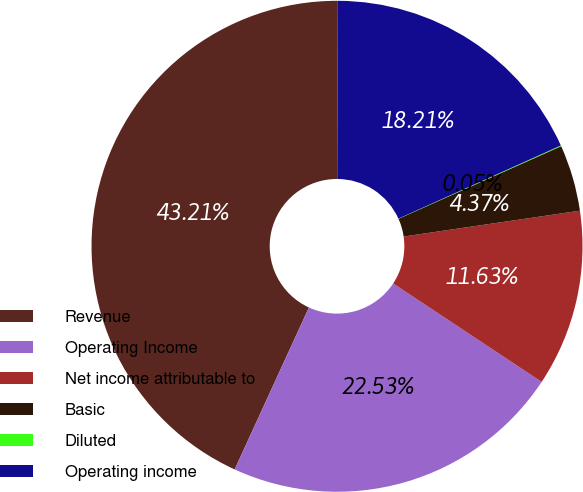Convert chart to OTSL. <chart><loc_0><loc_0><loc_500><loc_500><pie_chart><fcel>Revenue<fcel>Operating Income<fcel>Net income attributable to<fcel>Basic<fcel>Diluted<fcel>Operating income<nl><fcel>43.21%<fcel>22.53%<fcel>11.63%<fcel>4.37%<fcel>0.05%<fcel>18.21%<nl></chart> 